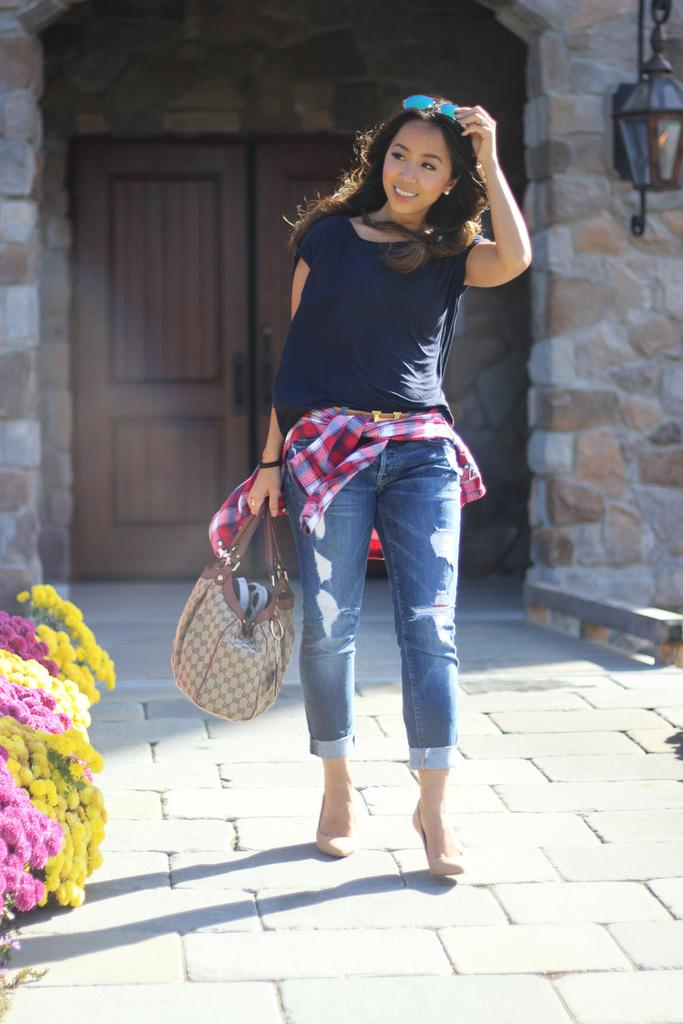Who is present in the image? There is a woman in the image. What is the woman doing? The woman is walking. How does the woman appear to be feeling? The woman has a smile on her face, suggesting she is happy or content. What is the woman carrying? The woman is holding a handbag. What can be seen in the background of the image? There are flowers and a door visible in the image. What type of butter is being used to treat the patient in the hospital in the image? There is no hospital or butter present in the image; it features a woman walking with a smile on her face. Can you point out the map that the woman is using to navigate in the image? There is no map visible in the image; the woman is simply walking with a handbag and a smile on her face. 